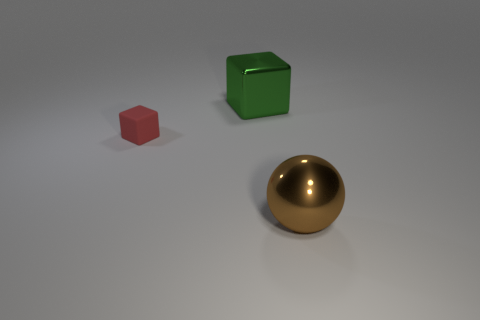Add 3 red matte blocks. How many objects exist? 6 Subtract all cubes. How many objects are left? 1 Subtract all red things. Subtract all large shiny blocks. How many objects are left? 1 Add 1 large objects. How many large objects are left? 3 Add 1 big yellow metal objects. How many big yellow metal objects exist? 1 Subtract 1 brown balls. How many objects are left? 2 